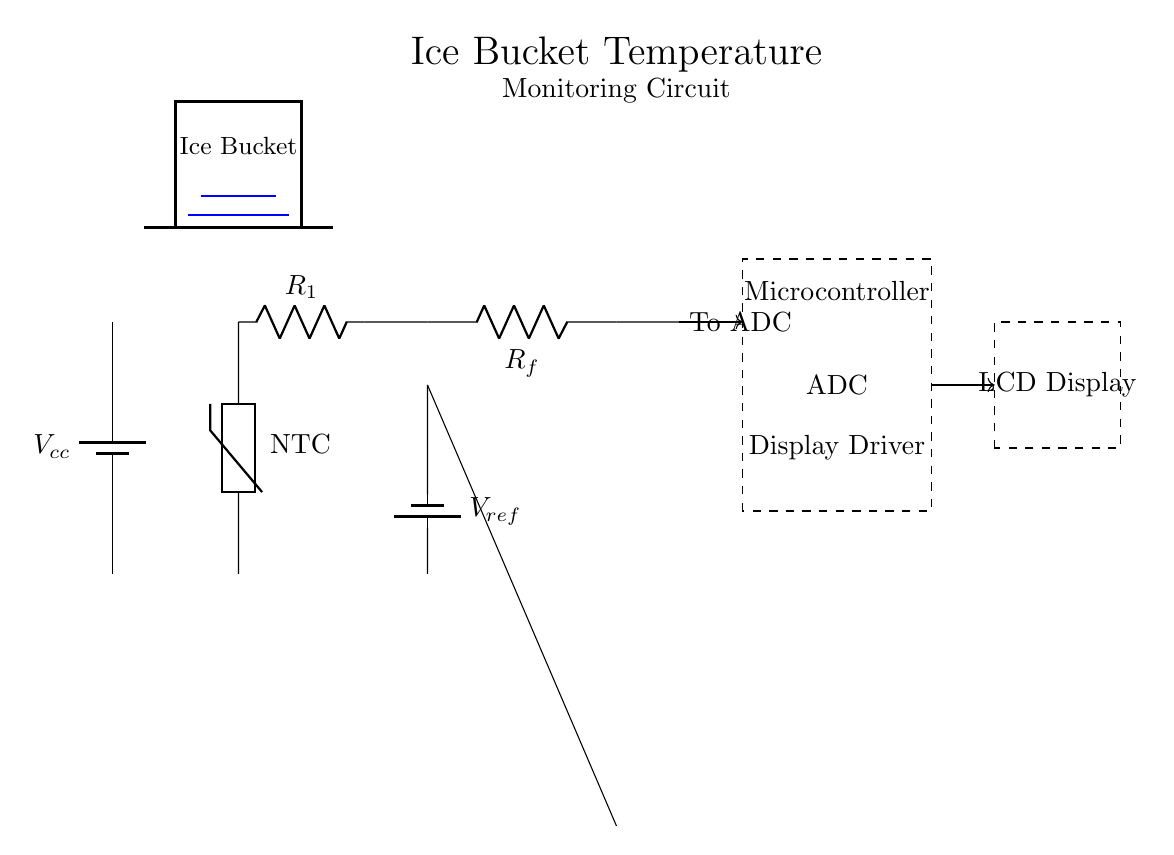What type of temperature sensor is used in this circuit? The temperature sensor in the circuit is labeled as "NTC," indicating it is a Negative Temperature Coefficient thermistor, which decreases resistance with increasing temperature.
Answer: NTC thermistor What is the purpose of the operational amplifier in this circuit? The operational amplifier amplifies the voltage signal received from the thermistor and resistor divider, enabling precise ADC measurements.
Answer: Signal amplification What is the reference voltage indicated in the circuit? The circuit indicates the reference voltage as "V ref," which is usually a known value used for comparison with the operational amplifier's input. The specific value is not provided in the circuit diagram.
Answer: V ref How many resistors are present in this circuit? There are two resistors illustrated in the diagram: R1, the voltage divider resistor, and Rf, the feedback resistor of the operational amplifier.
Answer: Two resistors What component converts the analog signal to a digital signal? The component that converts the analog signal to a digital signal is the ADC, which takes the amplified output from the operational amplifier and transforms it for digital display.
Answer: ADC What type of display is used to show the temperature? The circuit uses an LCD display to showcase the temperature readings from the ADC after processing the signal from the sensor.
Answer: LCD display Which component provides the power supply for the circuit? The power supply is provided by the battery labeled as "V cc," which delivers necessary voltage for the operation of the components in the circuit.
Answer: V cc 